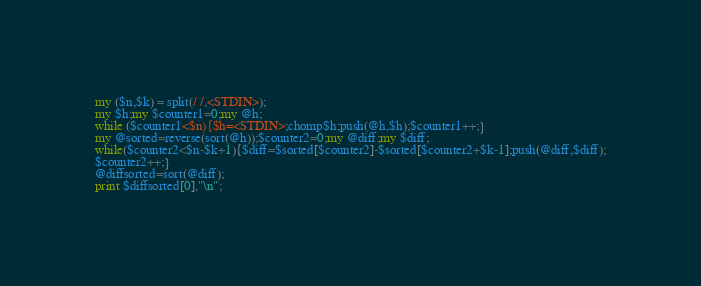<code> <loc_0><loc_0><loc_500><loc_500><_Perl_>my ($n,$k) = split(/ /,<STDIN>);
my $h;my $counter1=0;my @h;
while ($counter1<$n){$h=<STDIN>;chomp$h;push(@h,$h);$counter1++;}
my @sorted=reverse(sort(@h));$counter2=0;my @diff;my $diff;
while($counter2<$n-$k+1){$diff=$sorted[$counter2]-$sorted[$counter2+$k-1];push(@diff,$diff);
$counter2++;}
@diffsorted=sort(@diff);
print $diffsorted[0],"\n";</code> 